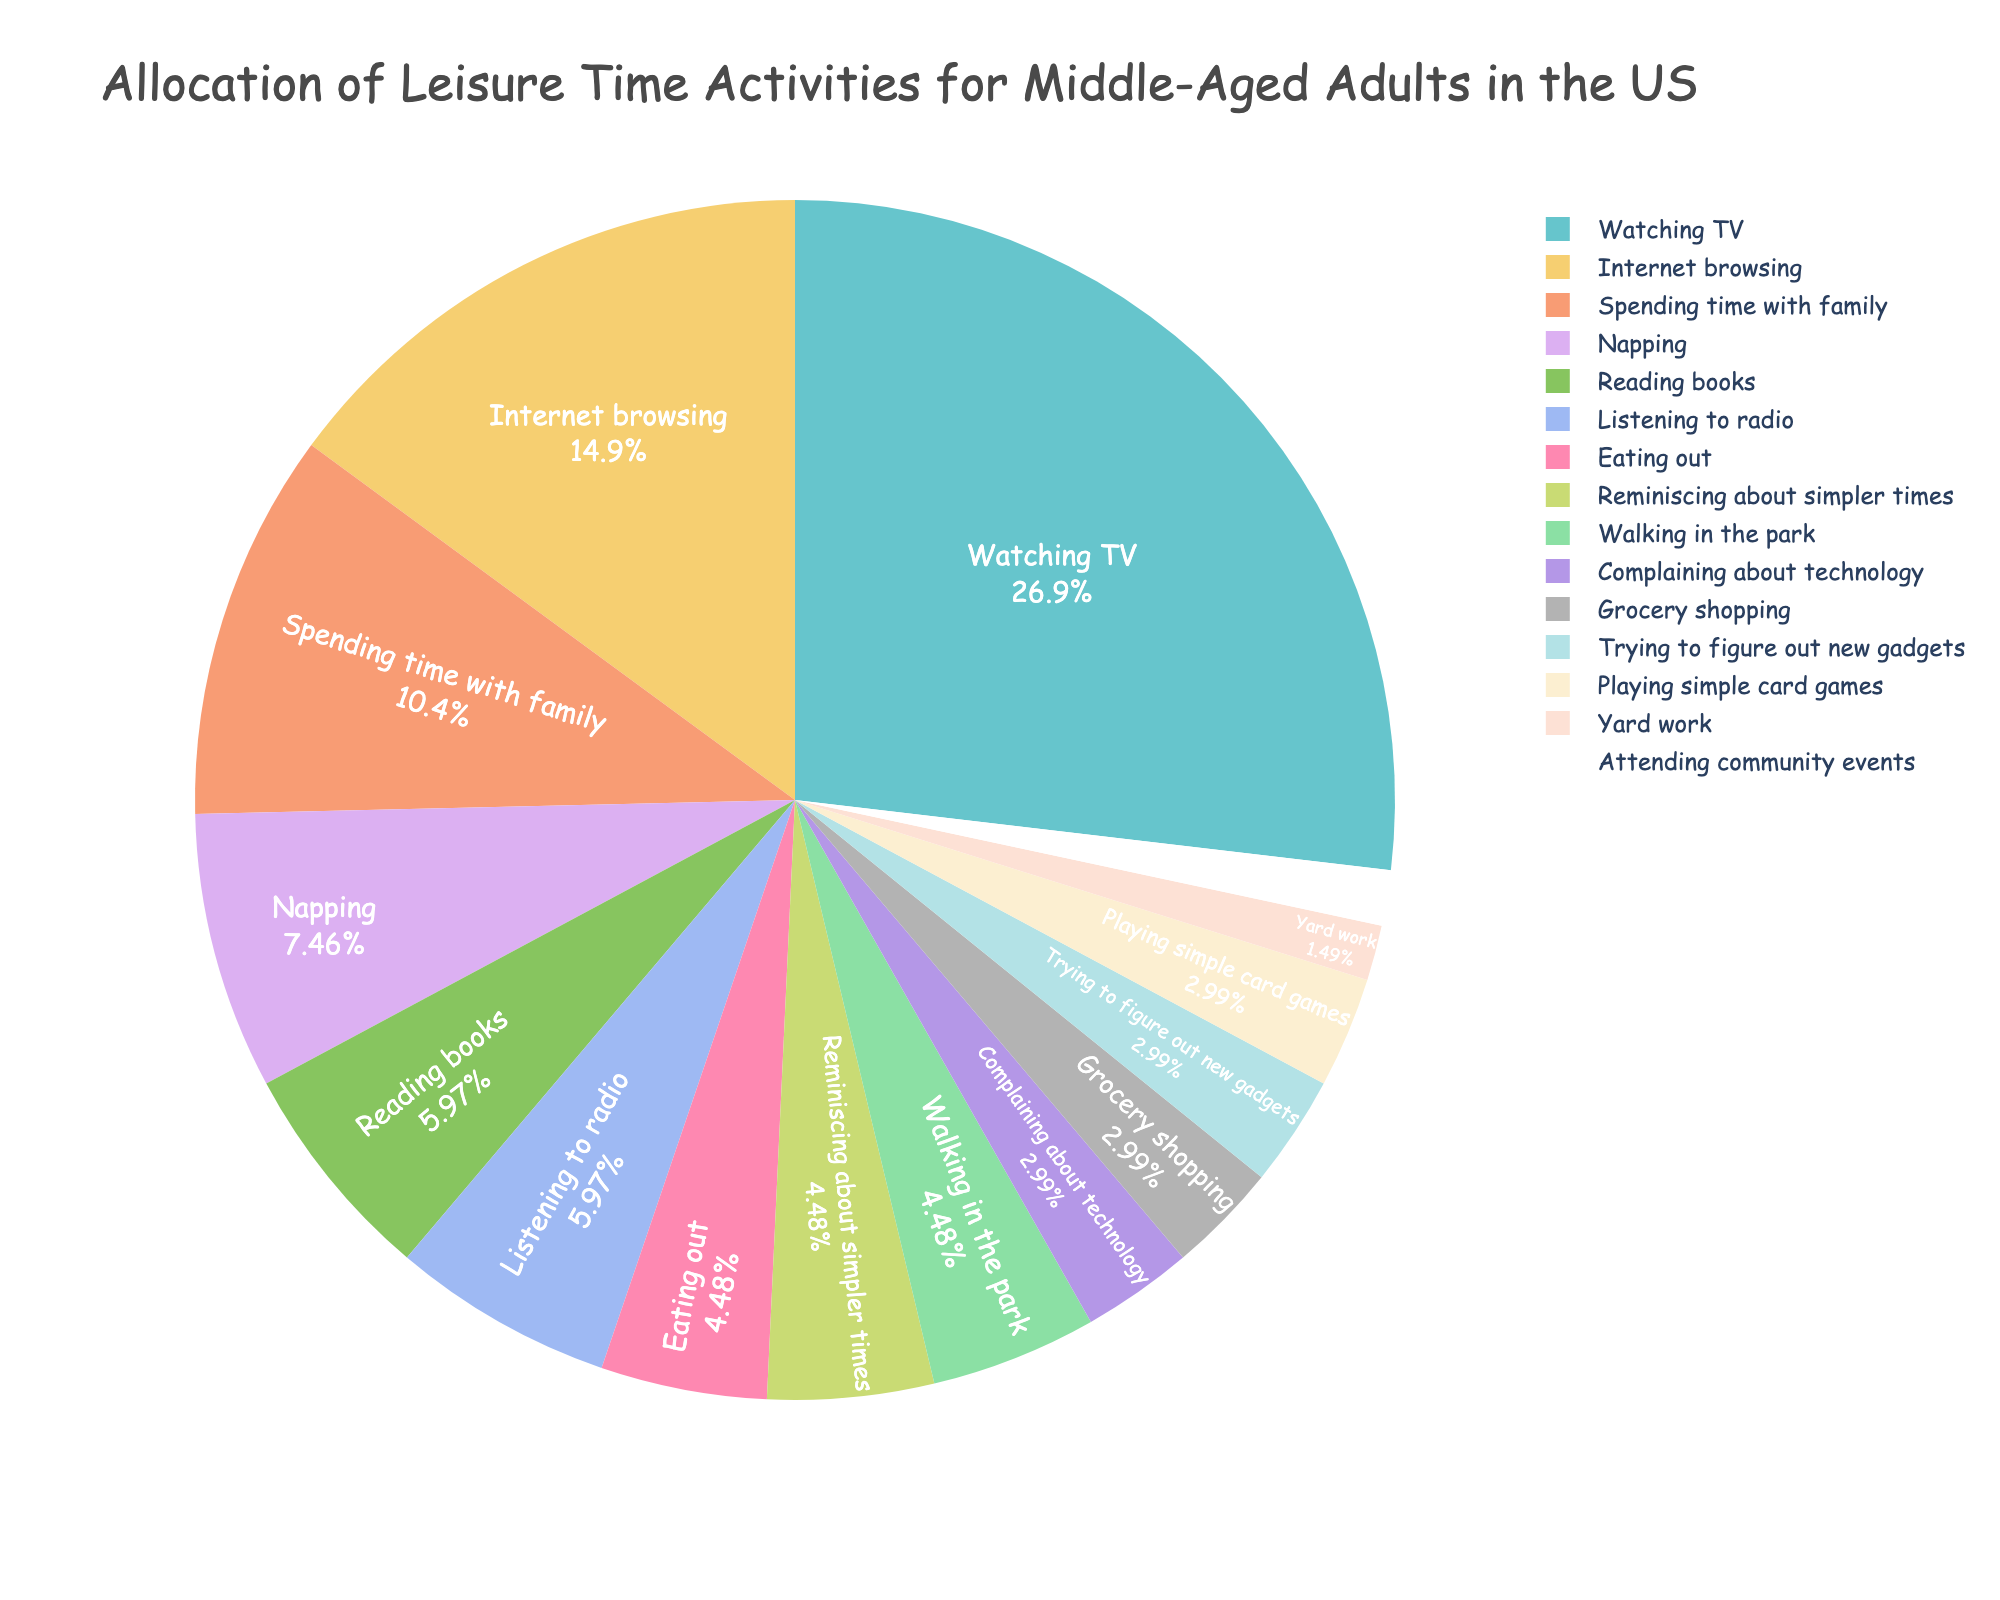what is the total number of hours middle-aged adults spend walking in the park and attending community events per week? To find the total number of hours, add the hours spent walking in the park (3 hours) and attending community events (1 hour). This gives us 3 + 1 = 4 hours.
Answer: 4 hours Which activity do middle-aged adults spend the most time on? By examining the chart, we see that the activity with the highest proportion of time is "Watching TV" with 18 hours per week.
Answer: Watching TV How much more time do middle-aged adults spend napping compared to playing simple card games per week? To calculate this, subtract the hours spent playing simple card games (2 hours) from the hours spent napping (5 hours). This gives us 5 - 2 = 3 hours.
Answer: 3 hours What percentage of the leisure time is allocated to listening to the radio? The chart provides this directly by showing the percentage next to the "Listening to radio" slice.
Answer: % (assuming the slice label will be in % format) Between spending time with family and napping, which one does middle-aged adults prefer based on the number of hours? The chart shows that spending time with family accounts for 7 hours per week, while napping takes up 5 hours. Therefore, spending time with family is preferred.
Answer: Spending time with family How much time do middle-aged adults spend complaining about technology and trying to figure out new gadgets combined? To find the combined time, add the hours spent complaining about technology (2 hours) and trying to figure out new gadgets (2 hours). This gives us 2 + 2 = 4 hours.
Answer: 4 hours Do middle-aged adults spend more time reading books or browsing the internet? By looking at the chart, we can compare the hours: reading books (4 hours) and browsing the internet (10 hours). Browsing the internet takes more time.
Answer: Browsing the internet Add up the total hours spent on eating out, grocery shopping, and yard work. Sum the hours for eating out (3 hours), grocery shopping (2 hours), and yard work (1 hour). This results in 3 + 2 + 1 = 6 hours.
Answer: 6 hours What activity do middle-aged adults spend the least amount of time on? The chart shows that the activity with the smallest fraction of time is "Yard work," which takes up 1 hour per week.
Answer: Yard work 